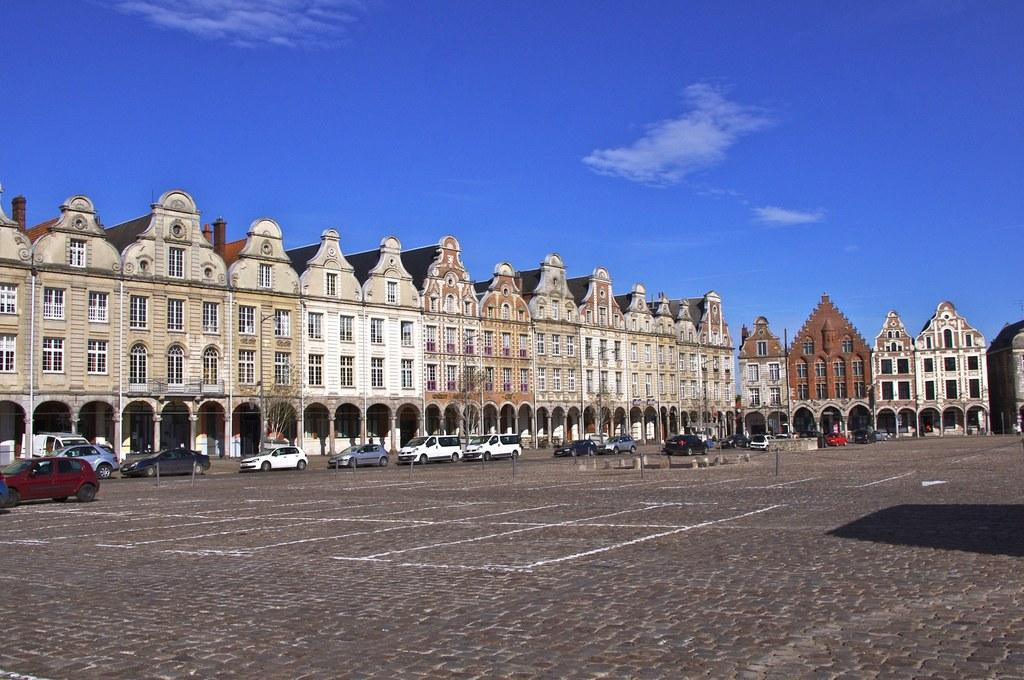What type of structures can be seen in the image? There are buildings in the image. What else can be seen on the path in the image? There are vehicles on the path in the image. What type of vegetation is present in the image? There are trees in the image. What is visible in the background of the image? The sky is visible in the background of the image. Where is the scarecrow located in the image? There is no scarecrow present in the image. How many knots are tied on the trees in the image? There are no knots visible on the trees in the image. 